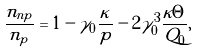Convert formula to latex. <formula><loc_0><loc_0><loc_500><loc_500>\frac { n _ { n p } } { n _ { p } } = 1 - \gamma _ { 0 } \frac { \kappa } { p } - 2 \gamma _ { 0 } ^ { 3 } \frac { \kappa \Theta } { Q _ { 0 } } ,</formula> 